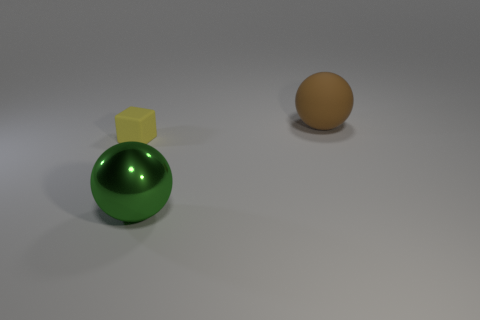Subtract 2 balls. How many balls are left? 0 Subtract all green spheres. How many spheres are left? 1 Subtract all cubes. How many objects are left? 2 Add 2 tiny cyan spheres. How many objects exist? 5 Subtract 1 brown balls. How many objects are left? 2 Subtract all gray blocks. Subtract all green cylinders. How many blocks are left? 1 Subtract all purple cylinders. How many green spheres are left? 1 Subtract all big gray metal cubes. Subtract all green metal objects. How many objects are left? 2 Add 3 shiny objects. How many shiny objects are left? 4 Add 1 small yellow blocks. How many small yellow blocks exist? 2 